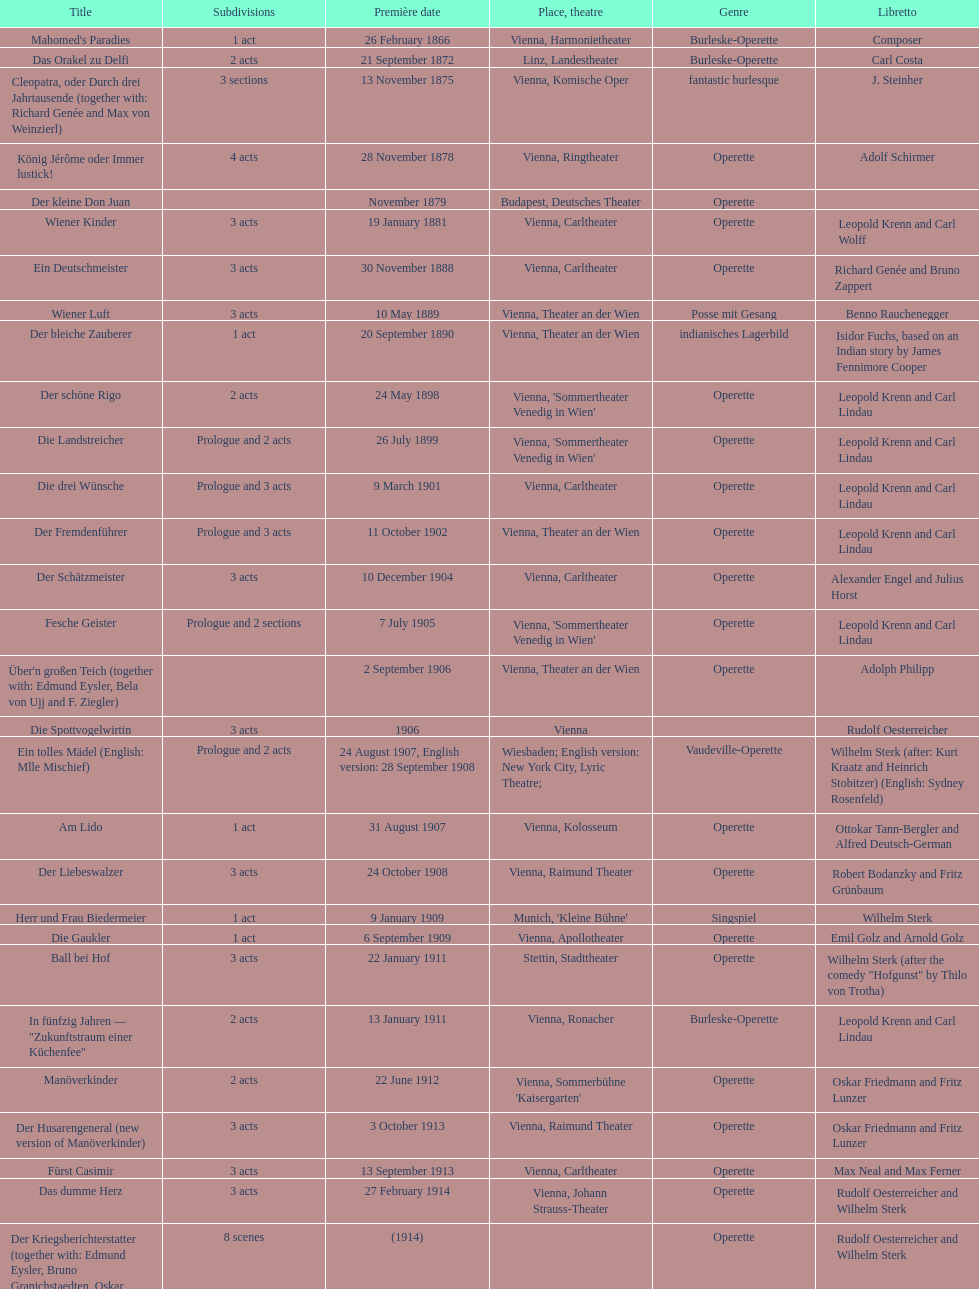Does der liebeswalzer or manöverkinder contain more acts? Der Liebeswalzer. 